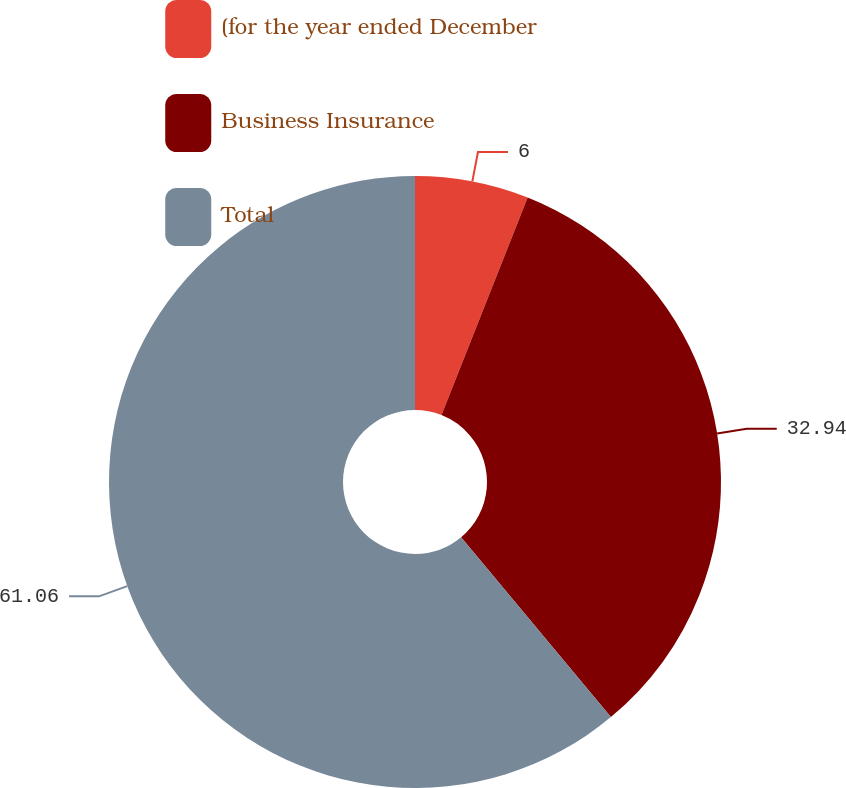Convert chart. <chart><loc_0><loc_0><loc_500><loc_500><pie_chart><fcel>(for the year ended December<fcel>Business Insurance<fcel>Total<nl><fcel>6.0%<fcel>32.94%<fcel>61.05%<nl></chart> 